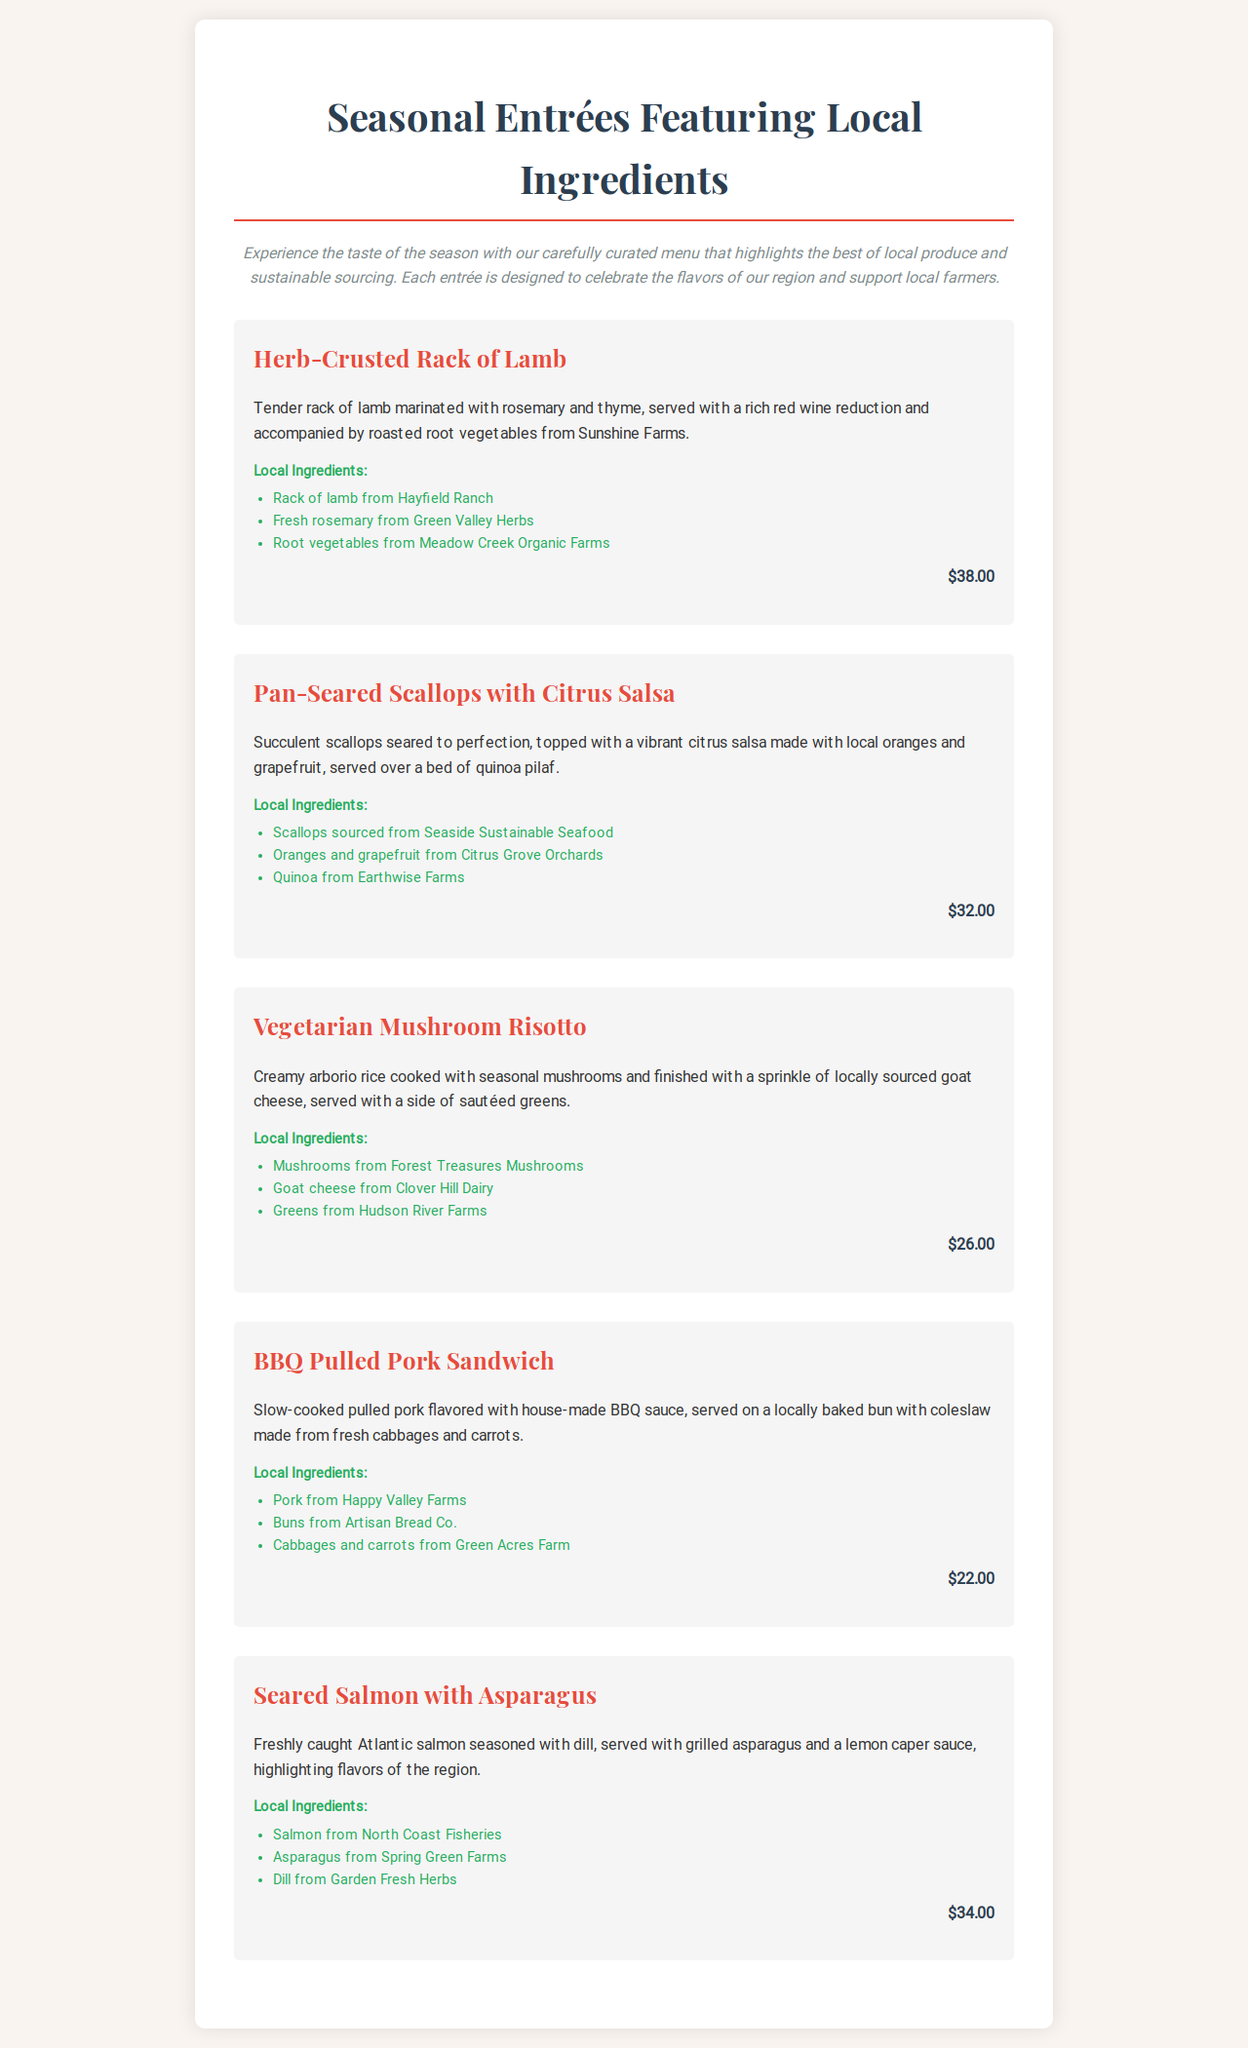What is the price of the Herb-Crusted Rack of Lamb? The price of the Herb-Crusted Rack of Lamb is listed in the document as $38.00.
Answer: $38.00 What local farm provides the pork for the BBQ Pulled Pork Sandwich? The document specifies that pork for the BBQ Pulled Pork Sandwich comes from Happy Valley Farms.
Answer: Happy Valley Farms How many seasonal entrées are featured in the document? By counting the different entrées listed in the document, we find there are five seasonal entrées.
Answer: Five Which entrée contains quinoa in its description? The Pan-Seared Scallops with Citrus Salsa is the entrée that includes quinoa pilaf in its description.
Answer: Pan-Seared Scallops with Citrus Salsa What ingredient is used in the Vegetarian Mushroom Risotto besides mushrooms? The description states that goat cheese is sprinkled in the Vegetarian Mushroom Risotto.
Answer: Goat cheese Which local ingredients are used in the Seared Salmon with Asparagus? The local ingredients listed for the Seared Salmon with Asparagus include salmon, asparagus, and dill.
Answer: Salmon, asparagus, and dill 